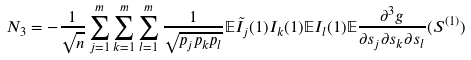<formula> <loc_0><loc_0><loc_500><loc_500>N _ { 3 } & = - \frac { 1 } { \sqrt { n } } \sum _ { j = 1 } ^ { m } \sum _ { k = 1 } ^ { m } \sum _ { l = 1 } ^ { m } \frac { 1 } { \sqrt { p _ { j } p _ { k } p _ { l } } } \mathbb { E } \tilde { I } _ { j } ( 1 ) I _ { k } ( 1 ) \mathbb { E } I _ { l } ( 1 ) \mathbb { E } \frac { \partial ^ { 3 } g } { \partial s _ { j } \partial s _ { k } \partial s _ { l } } ( S ^ { ( 1 ) } )</formula> 